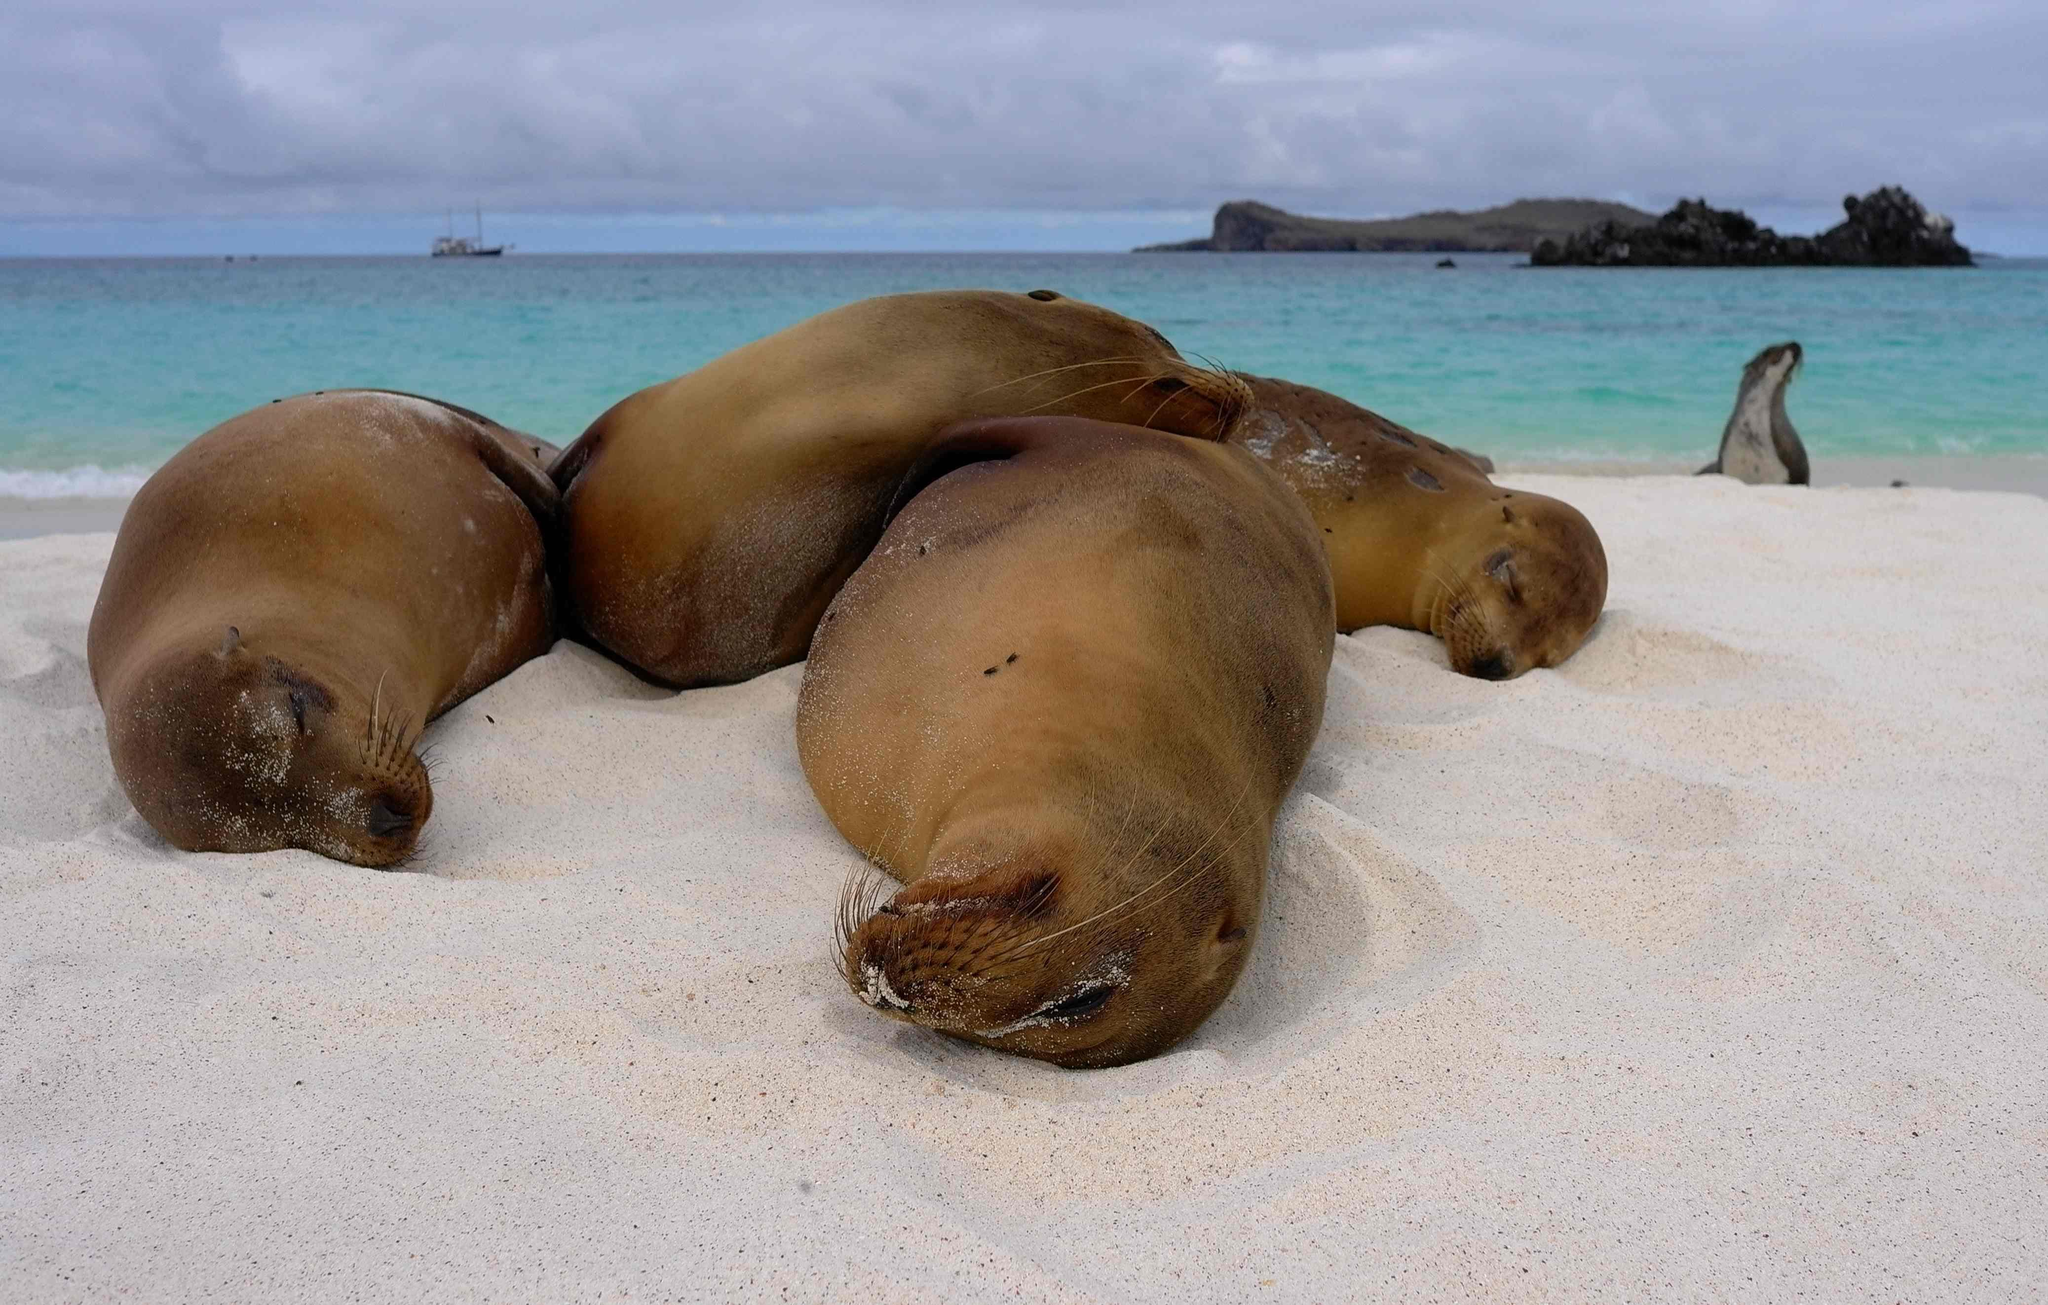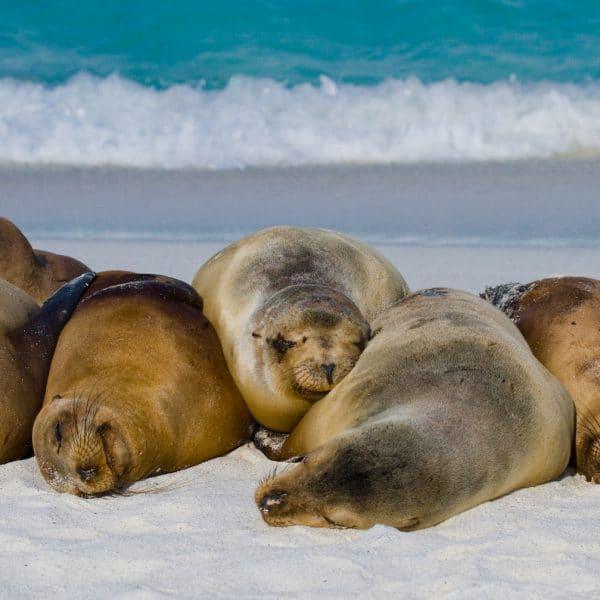The first image is the image on the left, the second image is the image on the right. For the images displayed, is the sentence "A single seal is sunning on a rock in the image on the left." factually correct? Answer yes or no. No. The first image is the image on the left, the second image is the image on the right. Analyze the images presented: Is the assertion "Left and right images show seals basking on rocks out of the water and include seals with their heads pointed toward the camera." valid? Answer yes or no. No. 